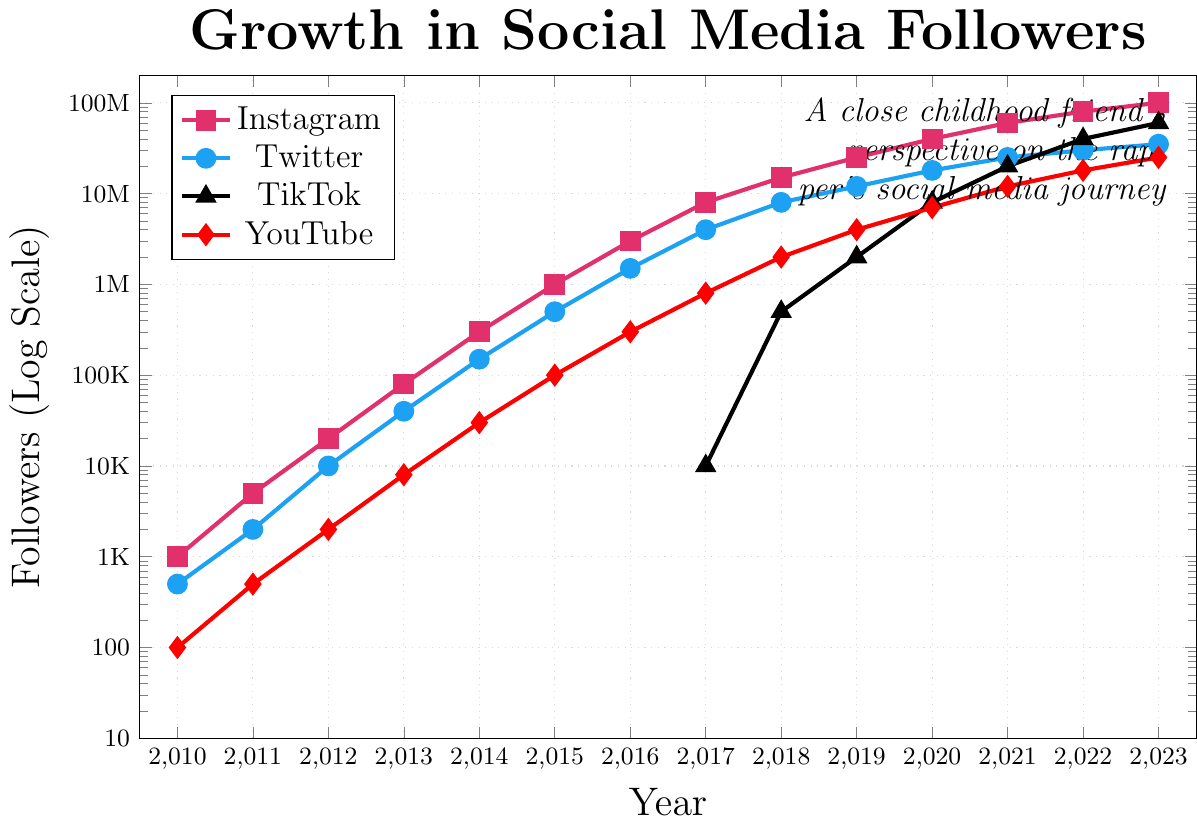What is the trend in Twitter followers between 2010 and 2023? To identify the trend, observe the blue data points for Twitter from 2010 to 2023. The number of Twitter followers increases consistently throughout these years. In 2010 it was 500, then rises to 35000000 in 2023, showing rapid growth.
Answer: Increasing trend Which platform had the highest number of followers in 2023? Look at the data points for each platform in 2023. Instagram (pink) has the highest number of followers with 100000000, compared to Twitter, TikTok, and YouTube.
Answer: Instagram In what year did TikTok followers first appear in significant numbers? Observe the black data points for TikTok. TikTok followers appear in significant numbers around 2017, where it reaches 10000 followers for the first time.
Answer: 2017 By how much did YouTube followers increase from 2010 to 2015? Check the red data points for YouTube in 2010 and 2015. In 2010, YouTube had 100 followers and in 2015 it had 100000 followers. The increase is 100000 - 100 = 99900 followers.
Answer: 99900 Between which two consecutive years did Instagram see the largest jump in followers? Analyze the pink data points for Instagram year by year. The largest jump occurs between 2015 (1000000 followers) and 2016 (3000000 followers), an increase of 2000000 followers.
Answer: 2015 to 2016 Which platform showed the fastest rate of growth between 2018 and 2023? Compare the slopes of all platforms between 2018 and 2023. TikTok (black) shows the fastest rate of growth, going from 500000 in 2018 to 60000000 in 2023.
Answer: TikTok What is the ratio of Instagram followers to Twitter followers in 2020? In 2020, Instagram has 40000000 followers and Twitter has 18000000. The ratio is 40000000 / 18000000 = 2.22.
Answer: 2.22 By how much did TikTok's followers increase from 2020 to 2022? Review the black data points for TikTok in 2020 and 2022. Followers in 2020 were 8000000, and in 2022 they were 40000000. The increase is 40000000 - 8000000 = 32000000.
Answer: 32000000 In which year did YouTube reach 1 million followers? Observe the red data points for YouTube. YouTube reached 1 million followers in 2015.
Answer: 2015 Which platform took the longest time to reach 1 million followers? Check the graph for each platform's first occurrence of 1 million followers. Twitter reached 1 million in 2015, Instagram in 2015 as well, TikTok in 2018, and YouTube in 2015. Twitter took from 2010 to 2015, the longest time.
Answer: Twitter 